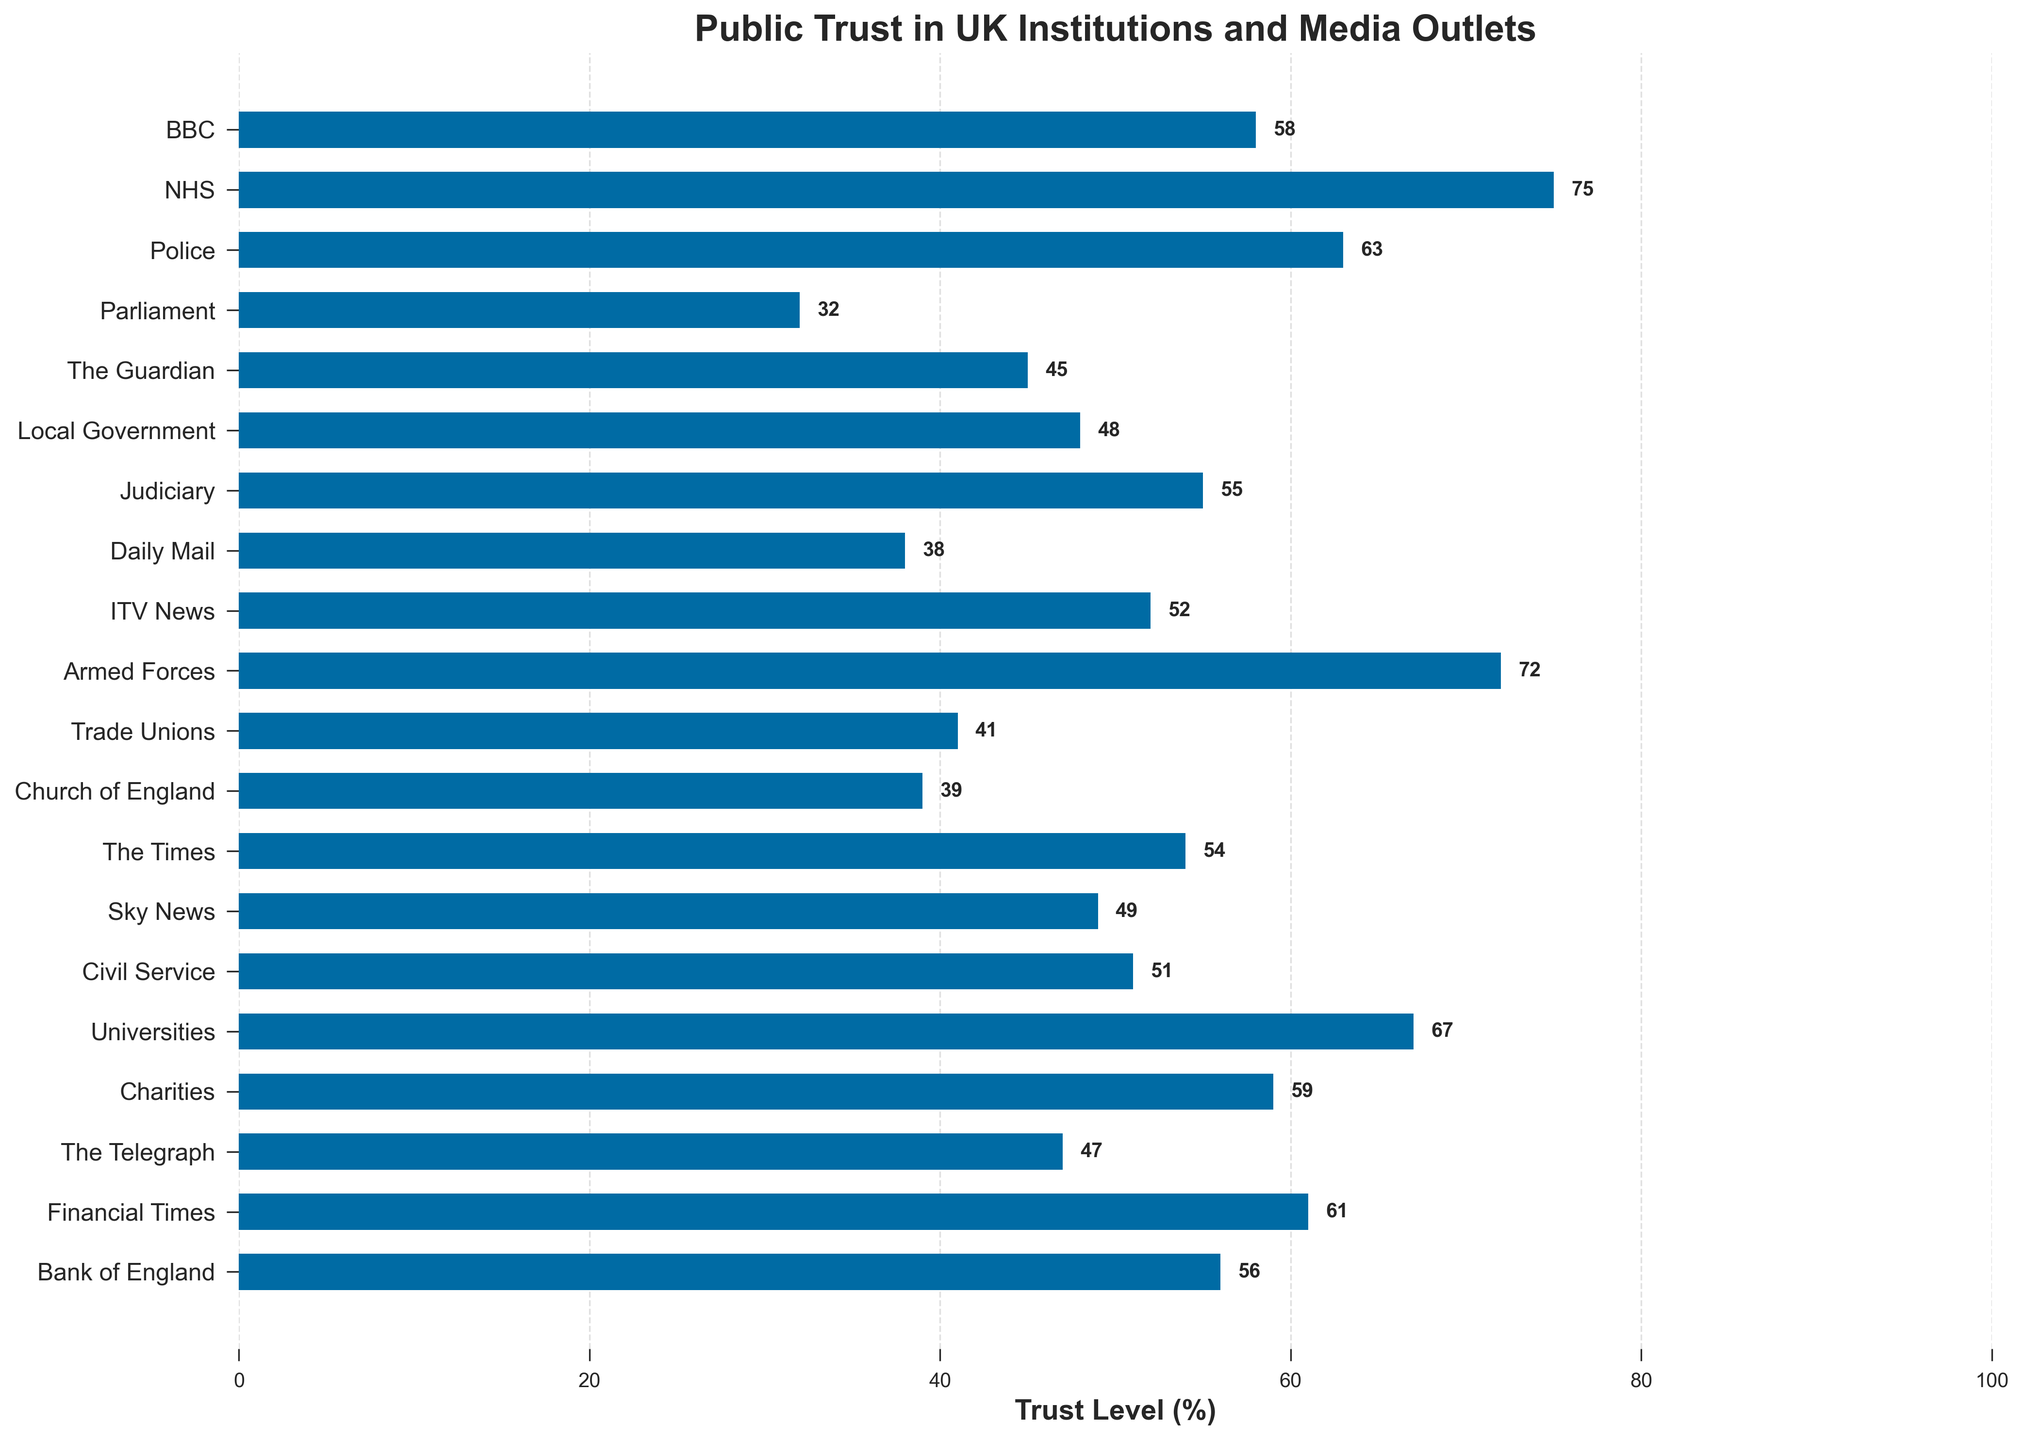Which institution has the highest trust level? To determine which institution has the highest trust level, scan the bars from top to bottom and identify the one with the longest bar. The NHS has the longest bar, indicating it has the highest trust level.
Answer: NHS Which media outlet has a higher trust level: BBC or ITV News? Look at the lengths of the bars and the labels next to them for the BBC and ITV News. The bar for the BBC is longer than the bar for ITV News.
Answer: BBC What is the trust level of local government and the judiciary combined? Find the trust levels of local government (48%) and the judiciary (55%). Add the two percentages together: 48 + 55 = 103%.
Answer: 103% Which institution’s trust level is closest to the median trust level of all institutions and media outlets? To find the median, first list all trust levels in ascending order: 32, 38, 39, 41, 45, 47, 48, 49, 51, 52, 54, 55, 56, 58, 59, 61, 63, 67, 72, 75. The median value, being the middle value in this ordered list, is the average of the 10th and 11th values (52 + 54) / 2 = 53%. The institution closest to this value is The Times with 54%.
Answer: The Times Which institution performs better in public trust, the Civil Service or Parliament? Compare the lengths of the bars for the Civil Service (51%) and Parliament (32%). The bar for the Civil Service is noticeably longer.
Answer: Civil Service How much higher is the trust level of Universities compared to the Church of England? Determine the trust levels for Universities (67%) and the Church of England (39%). Subtract the Church of England's trust level from Universities': 67 - 39 = 28%.
Answer: 28% What is the average trust level of media outlets listed in the figure? First identify the trust levels of BBC (58%), The Guardian (45%), Daily Mail (38%), ITV News (52%), Sky News (49%), The Times (54%), The Telegraph (47%), and Financial Times (61%). Sum these values: 58 + 45 + 38 + 52 + 49 + 54 + 47 + 61 = 404. Divide by 8 (the total number of media outlets): 404 / 8 = 50.5%.
Answer: 50.5% How does the trust level of the BBC compare to that of the NHS? Look at the lengths of the bars for the BBC (58%) and the NHS (75%). The NHS has a significantly longer bar than the BBC.
Answer: NHS has a higher trust level Which three institutions have the lowest trust levels? Find the shortest bars for Trust Levels: Parliament (32%), Daily Mail (38%), and Church of England (39%).
Answer: Parliament, Daily Mail, Church of England What is the difference in trust levels between the NHS and the Armed Forces? Which is higher? Compare the trust levels of the NHS (75%) and the Armed Forces (72%). Calculate the difference: 75 - 72 = 3%. The NHS has a slightly higher trust level.
Answer: 3%, NHS 